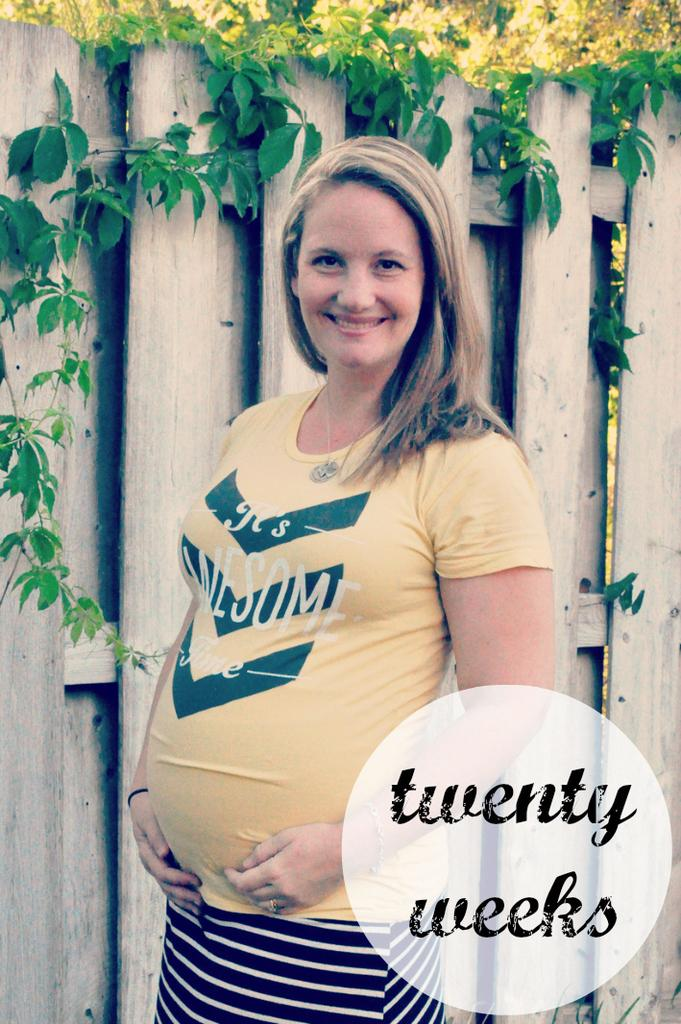<image>
Write a terse but informative summary of the picture. A pregnant woman wearing a shirt that says "It's Awesome Time" poses in front of a fence. 